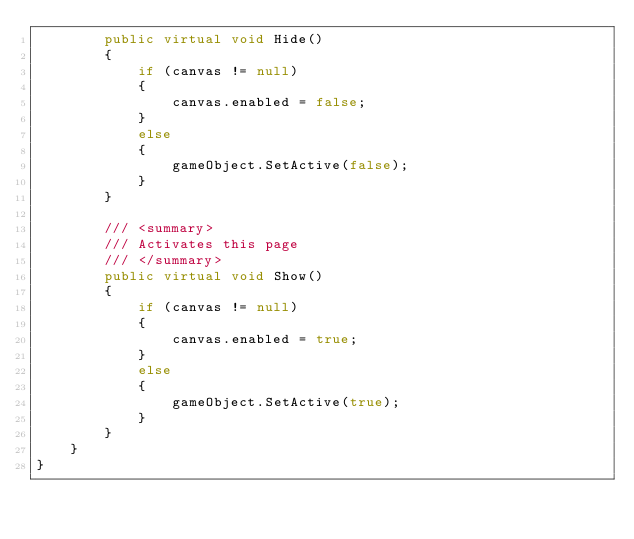<code> <loc_0><loc_0><loc_500><loc_500><_C#_>		public virtual void Hide()
		{
			if (canvas != null)
			{
				canvas.enabled = false;
			}
			else
			{
				gameObject.SetActive(false);
			}
		}

		/// <summary>
		/// Activates this page
		/// </summary>
		public virtual void Show()
		{
			if (canvas != null)
			{
				canvas.enabled = true;
			}
			else
			{
				gameObject.SetActive(true);
			}
		}
	}
}</code> 